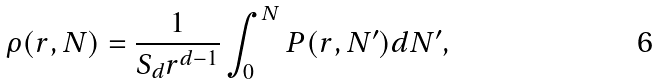<formula> <loc_0><loc_0><loc_500><loc_500>\rho ( r , N ) = \frac { 1 } { S _ { d } r ^ { d - 1 } } \int _ { 0 } ^ { N } P ( r , N ^ { \prime } ) d N ^ { \prime } ,</formula> 